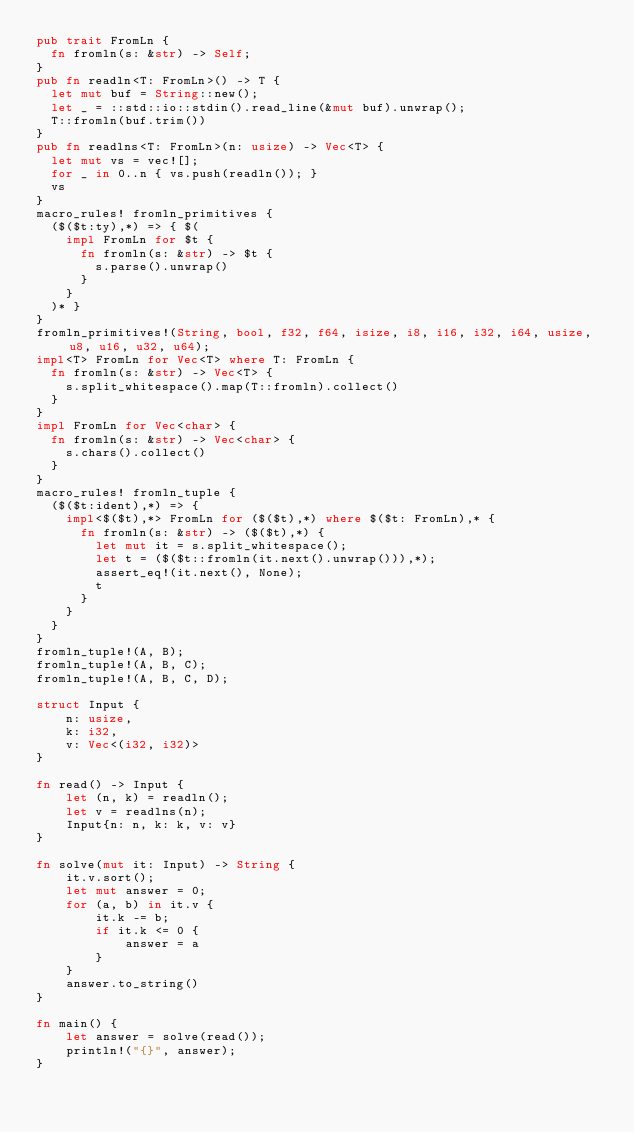<code> <loc_0><loc_0><loc_500><loc_500><_Rust_>pub trait FromLn {
	fn fromln(s: &str) -> Self;
}
pub fn readln<T: FromLn>() -> T {
	let mut buf = String::new();
	let _ = ::std::io::stdin().read_line(&mut buf).unwrap();
	T::fromln(buf.trim())
}
pub fn readlns<T: FromLn>(n: usize) -> Vec<T> {
	let mut vs = vec![];
	for _ in 0..n { vs.push(readln()); }
	vs
}
macro_rules! fromln_primitives {
	($($t:ty),*) => { $(
		impl FromLn for $t {
			fn fromln(s: &str) -> $t {
				s.parse().unwrap()
			}
		}
	)* }
}
fromln_primitives!(String, bool, f32, f64, isize, i8, i16, i32, i64, usize, u8, u16, u32, u64);
impl<T> FromLn for Vec<T> where T: FromLn {
	fn fromln(s: &str) -> Vec<T> {
		s.split_whitespace().map(T::fromln).collect()
	}
}
impl FromLn for Vec<char> {
	fn fromln(s: &str) -> Vec<char> {
		s.chars().collect()
	}
}
macro_rules! fromln_tuple {
	($($t:ident),*) => {
		impl<$($t),*> FromLn for ($($t),*) where $($t: FromLn),* {
			fn fromln(s: &str) -> ($($t),*) {
				let mut it = s.split_whitespace();
				let t = ($($t::fromln(it.next().unwrap())),*);
				assert_eq!(it.next(), None);
				t
			}
		}
	}
}
fromln_tuple!(A, B);
fromln_tuple!(A, B, C);
fromln_tuple!(A, B, C, D);

struct Input {
    n: usize,
    k: i32,
    v: Vec<(i32, i32)>
}

fn read() -> Input {
    let (n, k) = readln();
    let v = readlns(n);
    Input{n: n, k: k, v: v}
}

fn solve(mut it: Input) -> String {
    it.v.sort();
    let mut answer = 0;
    for (a, b) in it.v {
        it.k -= b;
        if it.k <= 0 {
            answer = a
        }
    }
    answer.to_string()
}

fn main() {
    let answer = solve(read());
    println!("{}", answer);
}
</code> 